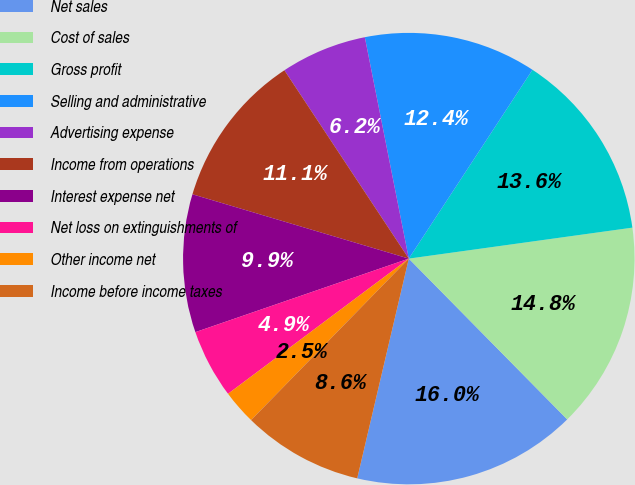<chart> <loc_0><loc_0><loc_500><loc_500><pie_chart><fcel>Net sales<fcel>Cost of sales<fcel>Gross profit<fcel>Selling and administrative<fcel>Advertising expense<fcel>Income from operations<fcel>Interest expense net<fcel>Net loss on extinguishments of<fcel>Other income net<fcel>Income before income taxes<nl><fcel>16.05%<fcel>14.81%<fcel>13.58%<fcel>12.35%<fcel>6.17%<fcel>11.11%<fcel>9.88%<fcel>4.94%<fcel>2.47%<fcel>8.64%<nl></chart> 